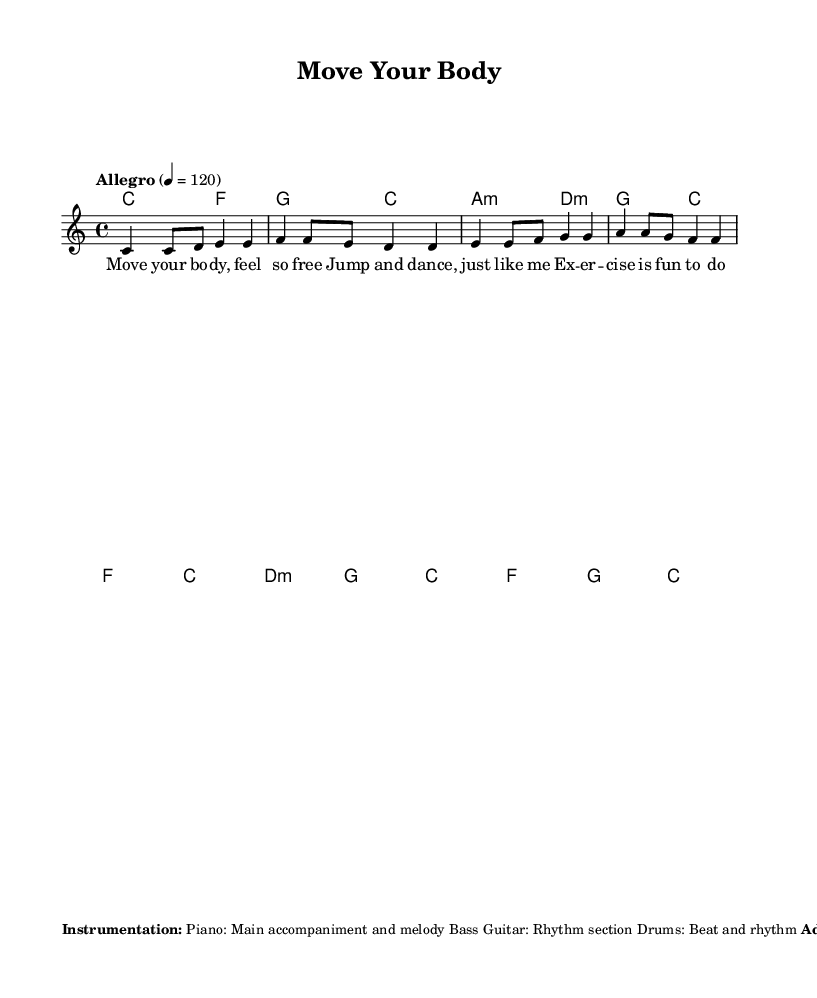What is the key signature of this music? The key signature is C major, which has no sharps or flats indicated at the beginning of the staff.
Answer: C major What is the time signature of this music? The time signature is indicated as 4/4, which can be recognized by the two numbers at the beginning of the staff where the top number indicates 4 beats per measure and the bottom number indicates a quarter note receives one beat.
Answer: 4/4 What is the tempo marking in this music? The tempo marking is "Allegro," which indicates a fast, lively pace, and a specific metronome marking of 120 beats per minute is also provided to guide the speed.
Answer: Allegro How many measures does the melody have in the provided section? By counting each vertical bar line in the melody section, we can identify that there are 8 measures in total.
Answer: 8 measures What type of chords are used in the harmonies section? The chords include major and minor chords, specifically indicated as C major, F major, G major, A minor, and D minor, showing a typical pop chord progression for an uplifting song.
Answer: Major and minor chords What additional elements enhance the rhythm of the song? The sheet music suggests adding handclaps or finger snaps on beats 2 and 4, which enhances the rhythm and encourages movement along with using upbeat, energetic drum patterns.
Answer: Handclaps and finger snaps What is the main theme of the lyrics in the song? The lyrics focus on promoting a healthy and active lifestyle through exercise and fun activities, as indicated by phrases like "Move your body" and "Healthy habits, just for you."
Answer: Promotion of a healthy lifestyle 